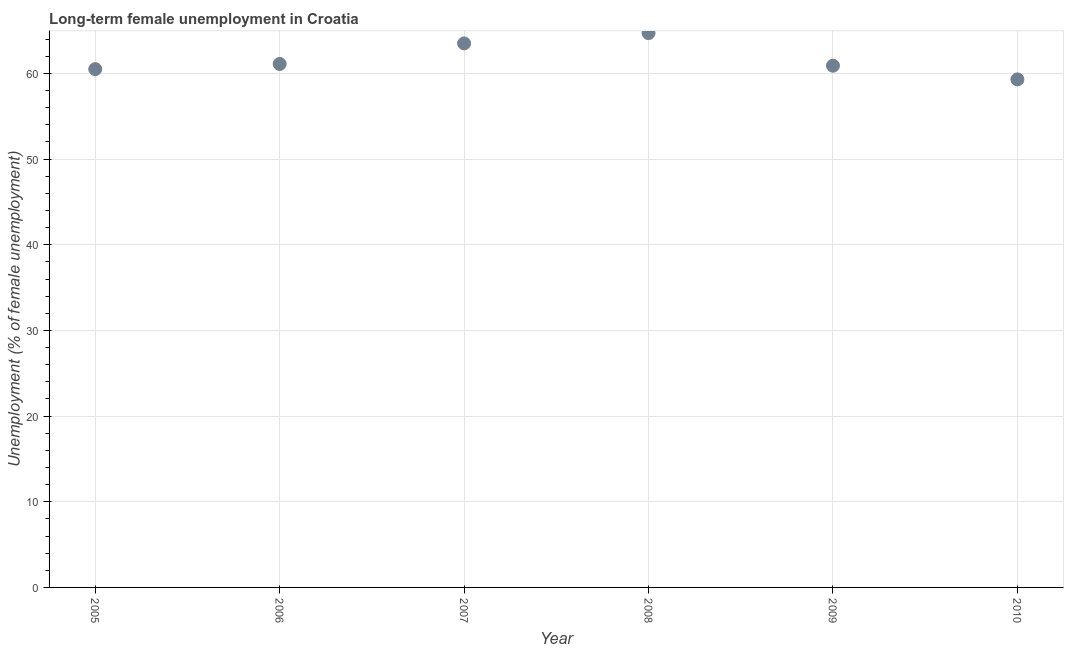What is the long-term female unemployment in 2009?
Give a very brief answer. 60.9. Across all years, what is the maximum long-term female unemployment?
Provide a short and direct response. 64.7. Across all years, what is the minimum long-term female unemployment?
Make the answer very short. 59.3. In which year was the long-term female unemployment maximum?
Provide a succinct answer. 2008. In which year was the long-term female unemployment minimum?
Your answer should be very brief. 2010. What is the sum of the long-term female unemployment?
Give a very brief answer. 370. What is the difference between the long-term female unemployment in 2005 and 2006?
Offer a very short reply. -0.6. What is the average long-term female unemployment per year?
Provide a short and direct response. 61.67. What is the median long-term female unemployment?
Give a very brief answer. 61. What is the ratio of the long-term female unemployment in 2008 to that in 2009?
Keep it short and to the point. 1.06. Is the difference between the long-term female unemployment in 2005 and 2007 greater than the difference between any two years?
Ensure brevity in your answer.  No. What is the difference between the highest and the second highest long-term female unemployment?
Your answer should be compact. 1.2. Is the sum of the long-term female unemployment in 2006 and 2007 greater than the maximum long-term female unemployment across all years?
Make the answer very short. Yes. What is the difference between the highest and the lowest long-term female unemployment?
Provide a short and direct response. 5.4. What is the difference between two consecutive major ticks on the Y-axis?
Give a very brief answer. 10. Are the values on the major ticks of Y-axis written in scientific E-notation?
Your response must be concise. No. Does the graph contain grids?
Offer a terse response. Yes. What is the title of the graph?
Your answer should be very brief. Long-term female unemployment in Croatia. What is the label or title of the Y-axis?
Give a very brief answer. Unemployment (% of female unemployment). What is the Unemployment (% of female unemployment) in 2005?
Offer a terse response. 60.5. What is the Unemployment (% of female unemployment) in 2006?
Keep it short and to the point. 61.1. What is the Unemployment (% of female unemployment) in 2007?
Your response must be concise. 63.5. What is the Unemployment (% of female unemployment) in 2008?
Provide a short and direct response. 64.7. What is the Unemployment (% of female unemployment) in 2009?
Ensure brevity in your answer.  60.9. What is the Unemployment (% of female unemployment) in 2010?
Offer a terse response. 59.3. What is the difference between the Unemployment (% of female unemployment) in 2005 and 2008?
Keep it short and to the point. -4.2. What is the difference between the Unemployment (% of female unemployment) in 2005 and 2009?
Offer a very short reply. -0.4. What is the difference between the Unemployment (% of female unemployment) in 2006 and 2008?
Your answer should be very brief. -3.6. What is the difference between the Unemployment (% of female unemployment) in 2006 and 2010?
Give a very brief answer. 1.8. What is the difference between the Unemployment (% of female unemployment) in 2007 and 2008?
Provide a short and direct response. -1.2. What is the difference between the Unemployment (% of female unemployment) in 2007 and 2009?
Your answer should be compact. 2.6. What is the difference between the Unemployment (% of female unemployment) in 2008 and 2009?
Your answer should be compact. 3.8. What is the difference between the Unemployment (% of female unemployment) in 2009 and 2010?
Your answer should be very brief. 1.6. What is the ratio of the Unemployment (% of female unemployment) in 2005 to that in 2007?
Ensure brevity in your answer.  0.95. What is the ratio of the Unemployment (% of female unemployment) in 2005 to that in 2008?
Give a very brief answer. 0.94. What is the ratio of the Unemployment (% of female unemployment) in 2005 to that in 2009?
Your answer should be compact. 0.99. What is the ratio of the Unemployment (% of female unemployment) in 2006 to that in 2008?
Provide a short and direct response. 0.94. What is the ratio of the Unemployment (% of female unemployment) in 2006 to that in 2010?
Your answer should be compact. 1.03. What is the ratio of the Unemployment (% of female unemployment) in 2007 to that in 2009?
Your response must be concise. 1.04. What is the ratio of the Unemployment (% of female unemployment) in 2007 to that in 2010?
Your response must be concise. 1.07. What is the ratio of the Unemployment (% of female unemployment) in 2008 to that in 2009?
Your answer should be very brief. 1.06. What is the ratio of the Unemployment (% of female unemployment) in 2008 to that in 2010?
Offer a terse response. 1.09. What is the ratio of the Unemployment (% of female unemployment) in 2009 to that in 2010?
Offer a terse response. 1.03. 